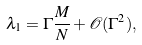Convert formula to latex. <formula><loc_0><loc_0><loc_500><loc_500>\lambda _ { 1 } = \Gamma \frac { M } { N } + \mathcal { O } ( \Gamma ^ { 2 } ) ,</formula> 